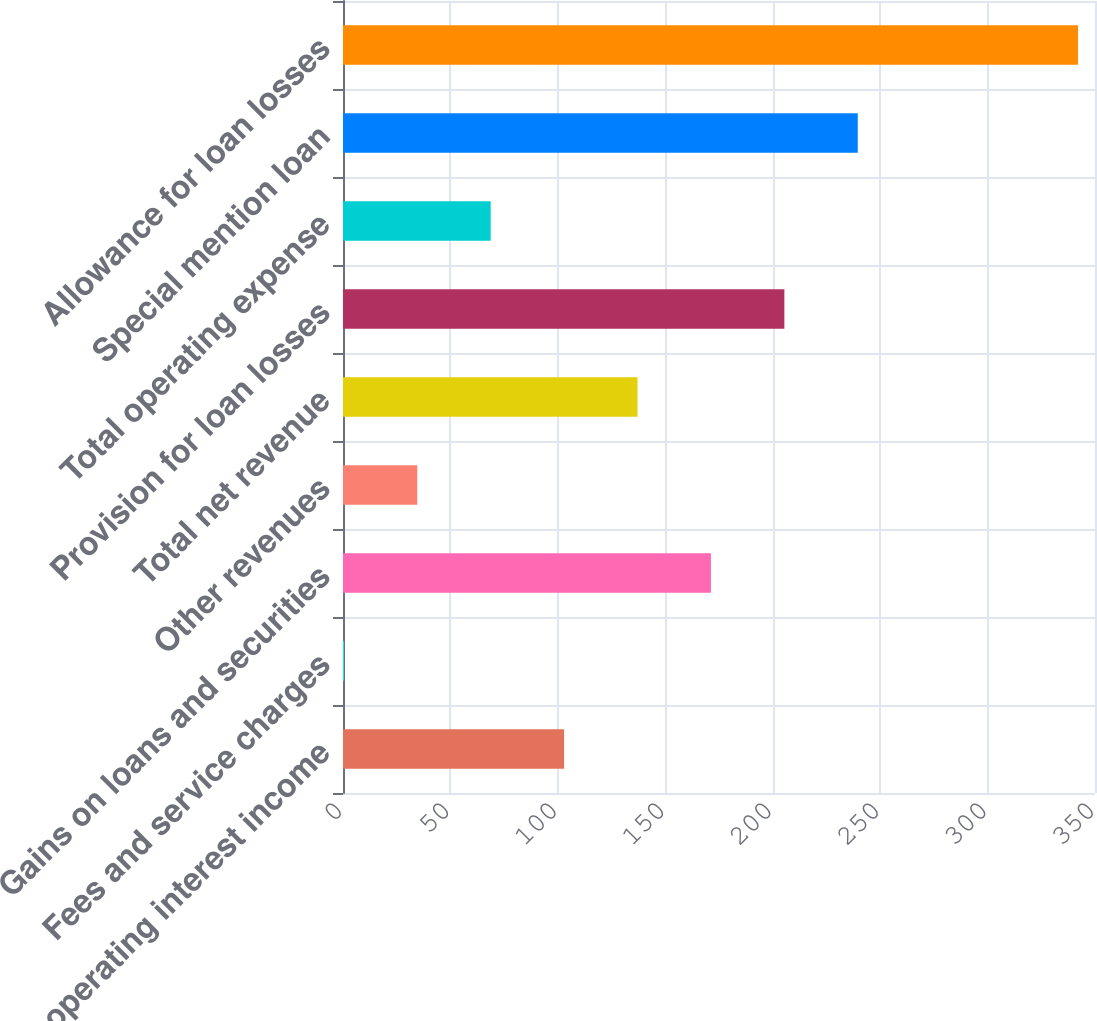Convert chart. <chart><loc_0><loc_0><loc_500><loc_500><bar_chart><fcel>Net operating interest income<fcel>Fees and service charges<fcel>Gains on loans and securities<fcel>Other revenues<fcel>Total net revenue<fcel>Provision for loan losses<fcel>Total operating expense<fcel>Special mention loan<fcel>Allowance for loan losses<nl><fcel>102.91<fcel>0.4<fcel>171.25<fcel>34.57<fcel>137.08<fcel>205.42<fcel>68.74<fcel>239.59<fcel>342.1<nl></chart> 